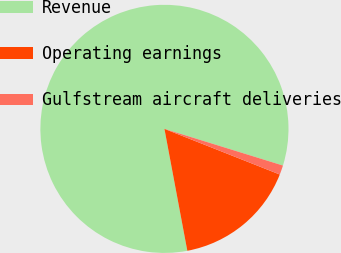Convert chart. <chart><loc_0><loc_0><loc_500><loc_500><pie_chart><fcel>Revenue<fcel>Operating earnings<fcel>Gulfstream aircraft deliveries<nl><fcel>82.73%<fcel>16.05%<fcel>1.22%<nl></chart> 